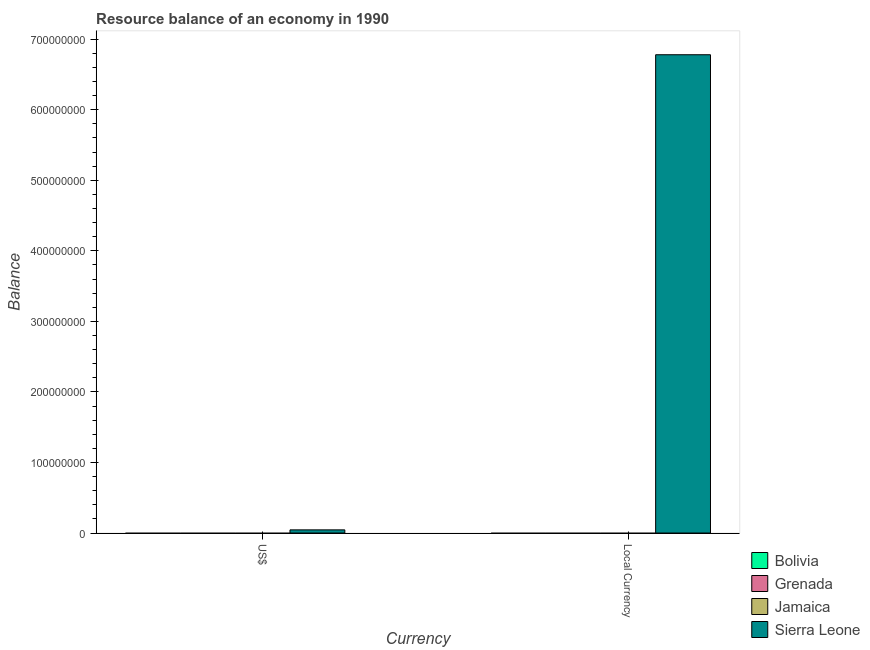How many different coloured bars are there?
Make the answer very short. 1. How many bars are there on the 1st tick from the left?
Your response must be concise. 1. What is the label of the 2nd group of bars from the left?
Provide a succinct answer. Local Currency. What is the resource balance in us$ in Bolivia?
Keep it short and to the point. 0. Across all countries, what is the maximum resource balance in us$?
Provide a short and direct response. 4.48e+06. Across all countries, what is the minimum resource balance in constant us$?
Your answer should be very brief. 0. In which country was the resource balance in us$ maximum?
Your answer should be very brief. Sierra Leone. What is the total resource balance in constant us$ in the graph?
Offer a terse response. 6.78e+08. What is the difference between the resource balance in us$ in Grenada and the resource balance in constant us$ in Jamaica?
Your response must be concise. 0. What is the average resource balance in us$ per country?
Your answer should be very brief. 1.12e+06. What is the difference between the resource balance in constant us$ and resource balance in us$ in Sierra Leone?
Provide a succinct answer. 6.74e+08. In how many countries, is the resource balance in us$ greater than the average resource balance in us$ taken over all countries?
Keep it short and to the point. 1. Are all the bars in the graph horizontal?
Make the answer very short. No. What is the difference between two consecutive major ticks on the Y-axis?
Provide a succinct answer. 1.00e+08. Are the values on the major ticks of Y-axis written in scientific E-notation?
Keep it short and to the point. No. Where does the legend appear in the graph?
Give a very brief answer. Bottom right. How many legend labels are there?
Provide a short and direct response. 4. How are the legend labels stacked?
Provide a succinct answer. Vertical. What is the title of the graph?
Provide a succinct answer. Resource balance of an economy in 1990. Does "United Arab Emirates" appear as one of the legend labels in the graph?
Make the answer very short. No. What is the label or title of the X-axis?
Keep it short and to the point. Currency. What is the label or title of the Y-axis?
Your response must be concise. Balance. What is the Balance in Grenada in US$?
Your response must be concise. 0. What is the Balance of Jamaica in US$?
Keep it short and to the point. 0. What is the Balance in Sierra Leone in US$?
Your answer should be very brief. 4.48e+06. What is the Balance of Bolivia in Local Currency?
Your answer should be compact. 0. What is the Balance of Sierra Leone in Local Currency?
Make the answer very short. 6.78e+08. Across all Currency, what is the maximum Balance in Sierra Leone?
Provide a succinct answer. 6.78e+08. Across all Currency, what is the minimum Balance of Sierra Leone?
Ensure brevity in your answer.  4.48e+06. What is the total Balance of Jamaica in the graph?
Ensure brevity in your answer.  0. What is the total Balance in Sierra Leone in the graph?
Give a very brief answer. 6.82e+08. What is the difference between the Balance in Sierra Leone in US$ and that in Local Currency?
Give a very brief answer. -6.74e+08. What is the average Balance of Bolivia per Currency?
Provide a succinct answer. 0. What is the average Balance of Grenada per Currency?
Your answer should be compact. 0. What is the average Balance in Jamaica per Currency?
Keep it short and to the point. 0. What is the average Balance of Sierra Leone per Currency?
Ensure brevity in your answer.  3.41e+08. What is the ratio of the Balance of Sierra Leone in US$ to that in Local Currency?
Make the answer very short. 0.01. What is the difference between the highest and the second highest Balance in Sierra Leone?
Provide a short and direct response. 6.74e+08. What is the difference between the highest and the lowest Balance in Sierra Leone?
Provide a succinct answer. 6.74e+08. 